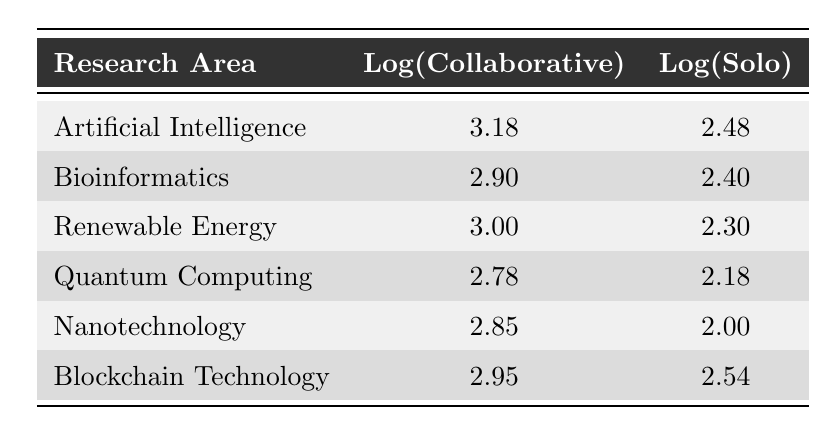What is the logarithmic value of collaborative papers in Artificial Intelligence? The table indicates that for the research area of Artificial Intelligence, the log value for collaborative papers is given as 3.18.
Answer: 3.18 How many solo-authored papers are there in Bioinformatics? According to the table, the number of solo-authored papers in the research area of Bioinformatics is listed as 250.
Answer: 250 Which research area has the highest log value for collaborative papers? By comparing the log values for collaborative papers across all research areas, Artificial Intelligence has the highest log value of 3.18.
Answer: Artificial Intelligence What is the difference between the log values of collaborative and solo papers in Blockchain Technology? For Blockchain Technology, the log value of collaborative papers is 2.95 and for solo papers is 2.54. The difference is calculated as 2.95 - 2.54 = 0.41.
Answer: 0.41 Is the number of collaborative papers higher in Renewable Energy compared to Quantum Computing? In Renewable Energy, there are 1000 collaborative papers, and in Quantum Computing, there are 600. Since 1000 is greater than 600, the statement is true.
Answer: Yes What is the average log value of solo-authored papers across all researched areas? The log values for solo-authored papers in each area are 2.48, 2.40, 2.30, 2.18, 2.00, and 2.54. The sum is 2.48 + 2.40 + 2.30 + 2.18 + 2.00 + 2.54 = 13.20. Dividing by the number of areas (6) gives an average of 13.20 / 6 = 2.20.
Answer: 2.20 Which research area shows the least number of solo-authored papers? By examining the table, the research area with the least number of solo-authored papers is Nanotechnology, which has 100 solo-authored papers.
Answer: Nanotechnology Are there more collaborative papers in AI than in Blockchain Technology? Collaborative papers in AI total 1500, while those in Blockchain Technology total 900. Since 1500 is greater than 900, the answer is yes.
Answer: Yes 